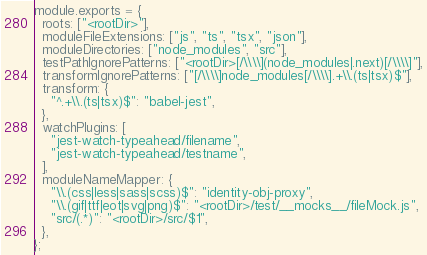<code> <loc_0><loc_0><loc_500><loc_500><_JavaScript_>module.exports = {
  roots: ["<rootDir>"],
  moduleFileExtensions: ["js", "ts", "tsx", "json"],
  moduleDirectories: ["node_modules", "src"],
  testPathIgnorePatterns: ["<rootDir>[/\\\\](node_modules|.next)[/\\\\]"],
  transformIgnorePatterns: ["[/\\\\]node_modules[/\\\\].+\\.(ts|tsx)$"],
  transform: {
    "^.+\\.(ts|tsx)$": "babel-jest",
  },
  watchPlugins: [
    "jest-watch-typeahead/filename",
    "jest-watch-typeahead/testname",
  ],
  moduleNameMapper: {
    "\\.(css|less|sass|scss)$": "identity-obj-proxy",
    "\\.(gif|ttf|eot|svg|png)$": "<rootDir>/test/__mocks__/fileMock.js",
    "src/(.*)": "<rootDir>/src/$1",
  },
};
</code> 